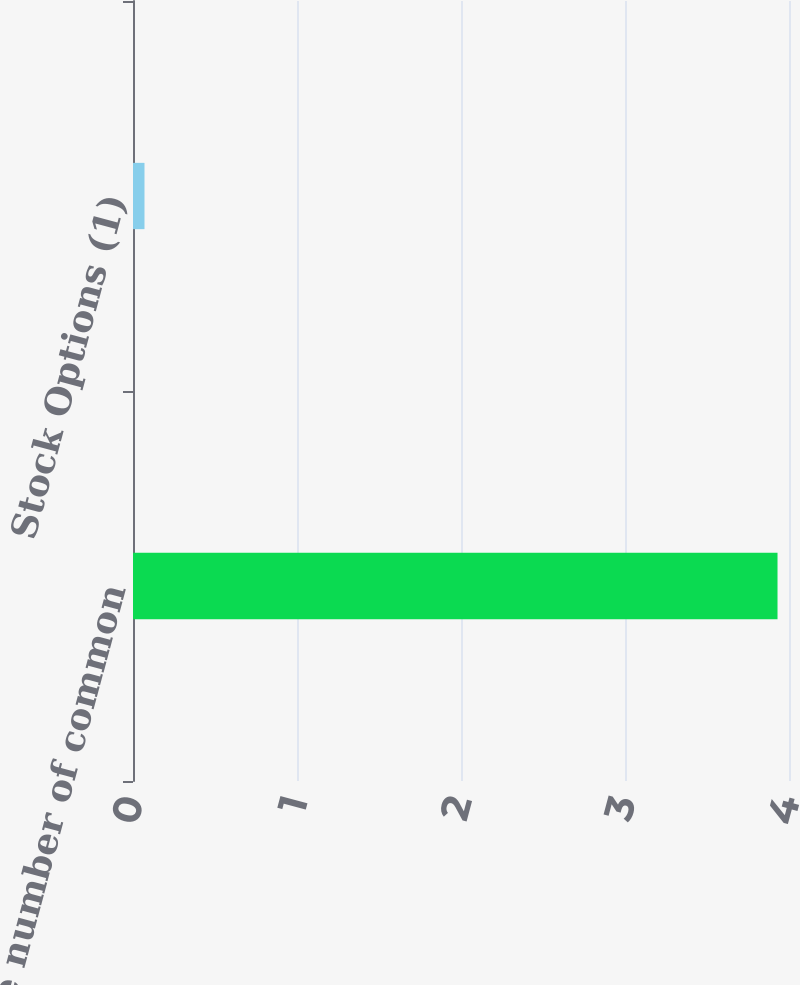Convert chart. <chart><loc_0><loc_0><loc_500><loc_500><bar_chart><fcel>Average number of common<fcel>Stock Options (1)<nl><fcel>3.93<fcel>0.07<nl></chart> 